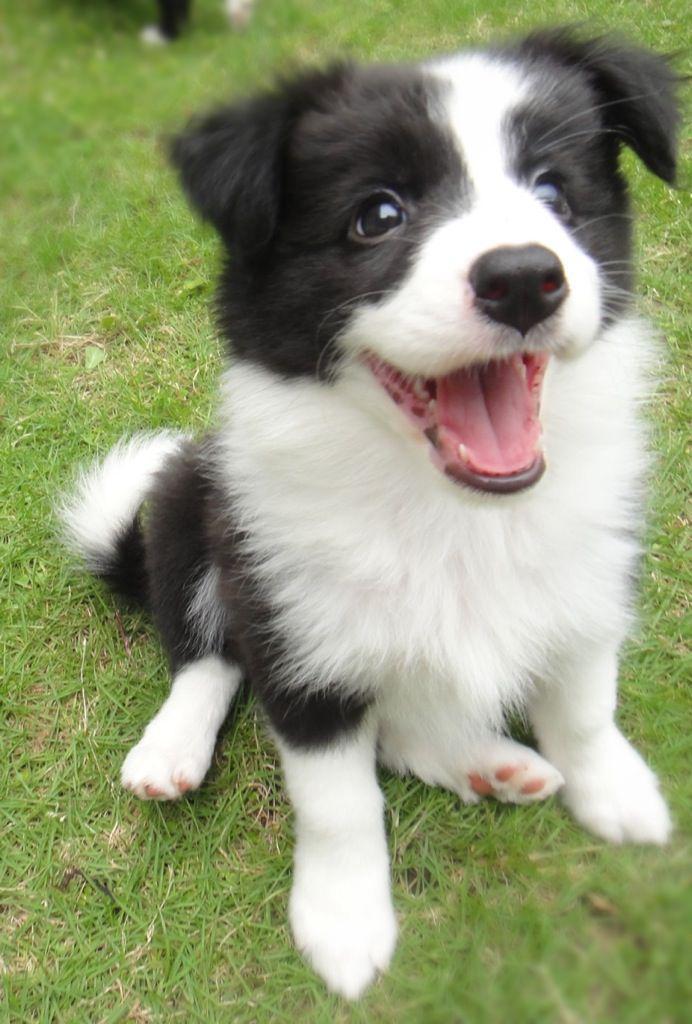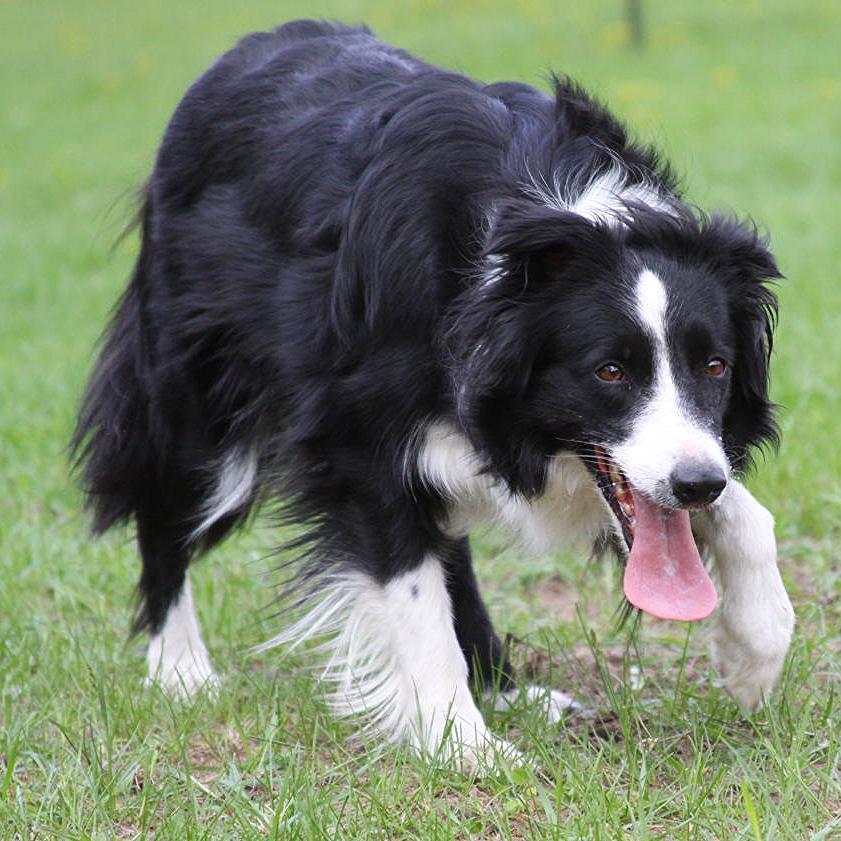The first image is the image on the left, the second image is the image on the right. Assess this claim about the two images: "The dog on the left has a leash around its neck.". Correct or not? Answer yes or no. No. The first image is the image on the left, the second image is the image on the right. Considering the images on both sides, is "There are two dogs in total." valid? Answer yes or no. Yes. 